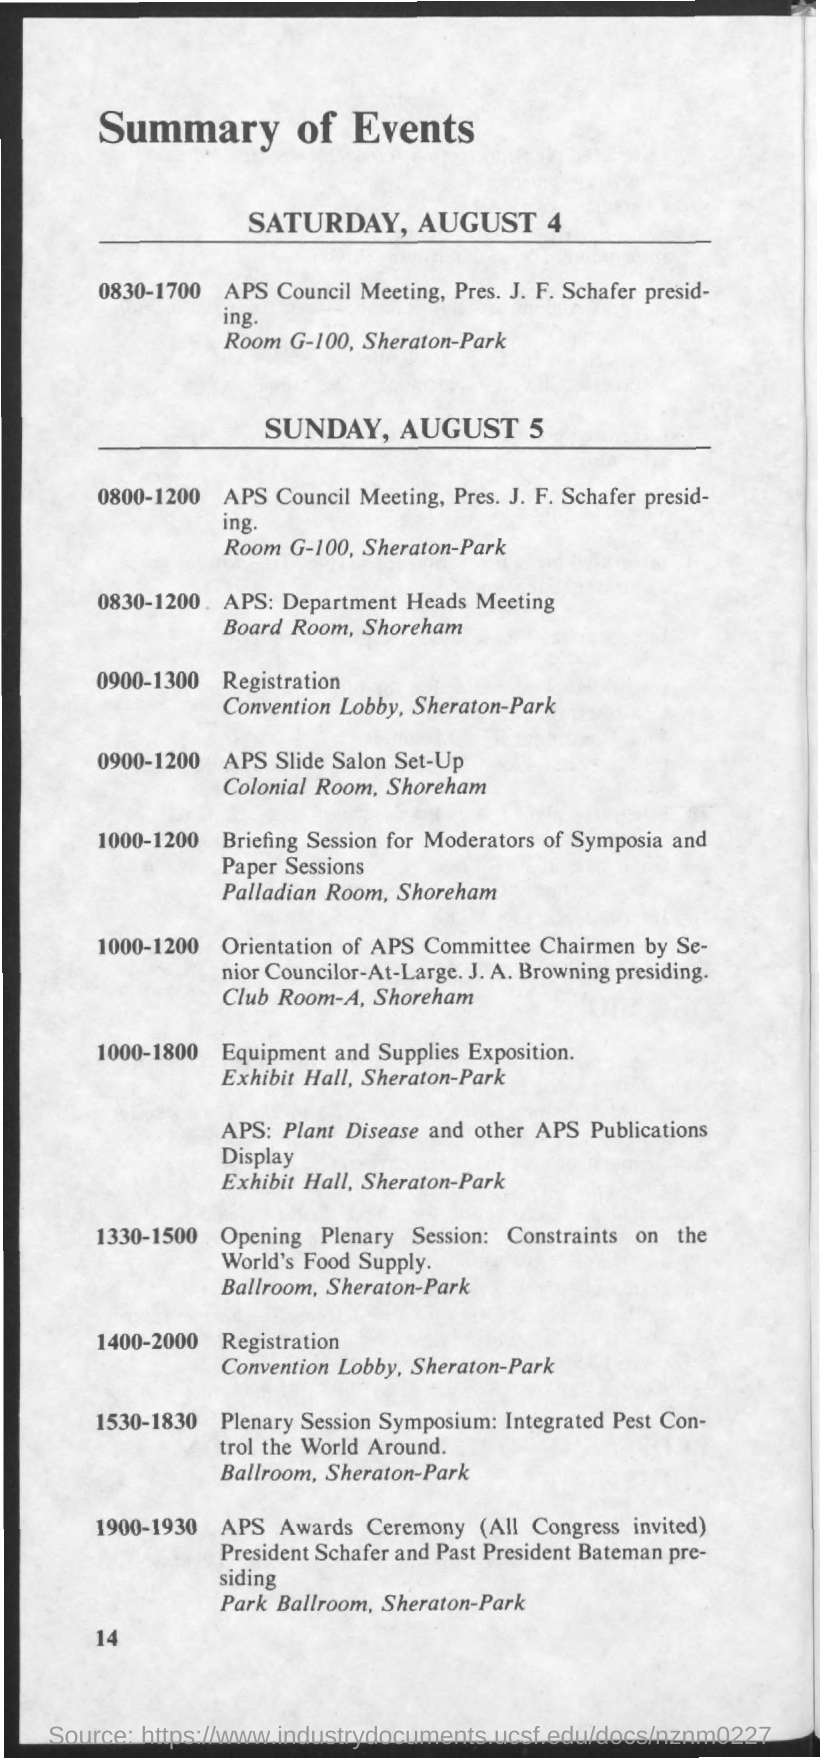Indicate a few pertinent items in this graphic. The date mentioned in the given page is Saturday, August 4. 